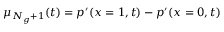<formula> <loc_0><loc_0><loc_500><loc_500>\mu _ { N _ { g } + 1 } ( t ) = p ^ { \prime } ( x = 1 , t ) - p ^ { \prime } ( x = 0 , t )</formula> 